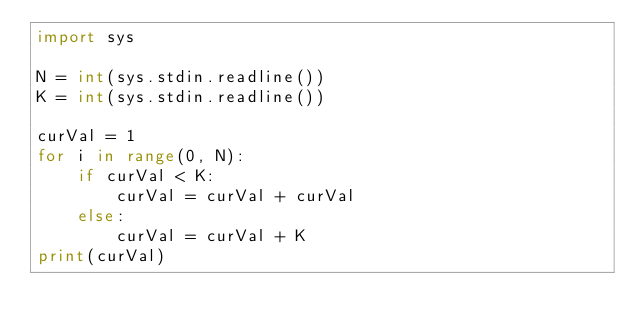<code> <loc_0><loc_0><loc_500><loc_500><_Python_>import sys

N = int(sys.stdin.readline())
K = int(sys.stdin.readline())

curVal = 1
for i in range(0, N):
    if curVal < K:
        curVal = curVal + curVal
    else:
        curVal = curVal + K
print(curVal)</code> 